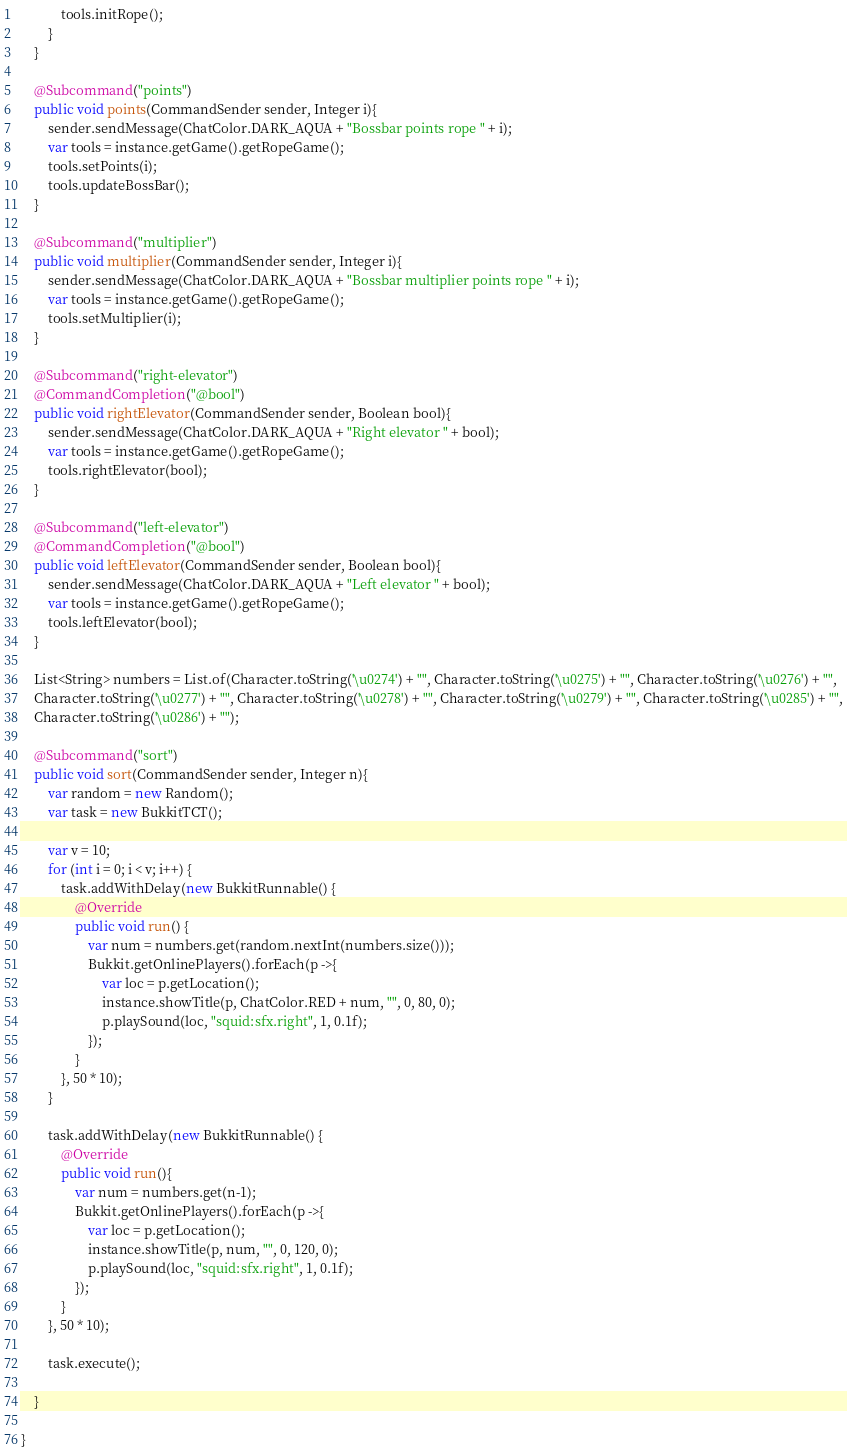Convert code to text. <code><loc_0><loc_0><loc_500><loc_500><_Java_>            tools.initRope();
        }
    }

    @Subcommand("points")
    public void points(CommandSender sender, Integer i){
        sender.sendMessage(ChatColor.DARK_AQUA + "Bossbar points rope " + i);
        var tools = instance.getGame().getRopeGame();
        tools.setPoints(i);
        tools.updateBossBar();
    }

    @Subcommand("multiplier")
    public void multiplier(CommandSender sender, Integer i){
        sender.sendMessage(ChatColor.DARK_AQUA + "Bossbar multiplier points rope " + i);
        var tools = instance.getGame().getRopeGame();
        tools.setMultiplier(i);
    }

    @Subcommand("right-elevator")
    @CommandCompletion("@bool")
    public void rightElevator(CommandSender sender, Boolean bool){
        sender.sendMessage(ChatColor.DARK_AQUA + "Right elevator " + bool);
        var tools = instance.getGame().getRopeGame();
        tools.rightElevator(bool);
    }

    @Subcommand("left-elevator")
    @CommandCompletion("@bool")
    public void leftElevator(CommandSender sender, Boolean bool){
        sender.sendMessage(ChatColor.DARK_AQUA + "Left elevator " + bool);
        var tools = instance.getGame().getRopeGame();
        tools.leftElevator(bool);
    }

    List<String> numbers = List.of(Character.toString('\u0274') + "", Character.toString('\u0275') + "", Character.toString('\u0276') + "", 
    Character.toString('\u0277') + "", Character.toString('\u0278') + "", Character.toString('\u0279') + "", Character.toString('\u0285') + "",
    Character.toString('\u0286') + "");
    
    @Subcommand("sort")
    public void sort(CommandSender sender, Integer n){
        var random = new Random();
        var task = new BukkitTCT();

        var v = 10;
        for (int i = 0; i < v; i++) {
            task.addWithDelay(new BukkitRunnable() {
                @Override
                public void run() {
                    var num = numbers.get(random.nextInt(numbers.size()));
                    Bukkit.getOnlinePlayers().forEach(p ->{
                        var loc = p.getLocation();
                        instance.showTitle(p, ChatColor.RED + num, "", 0, 80, 0);
                        p.playSound(loc, "squid:sfx.right", 1, 0.1f);
                    });
                }
            }, 50 * 10);
        }

        task.addWithDelay(new BukkitRunnable() {
            @Override
            public void run(){
                var num = numbers.get(n-1);
                Bukkit.getOnlinePlayers().forEach(p ->{
                    var loc = p.getLocation();
                    instance.showTitle(p, num, "", 0, 120, 0);
                    p.playSound(loc, "squid:sfx.right", 1, 0.1f);
                });
            }
        }, 50 * 10);

        task.execute();

    }

}
</code> 